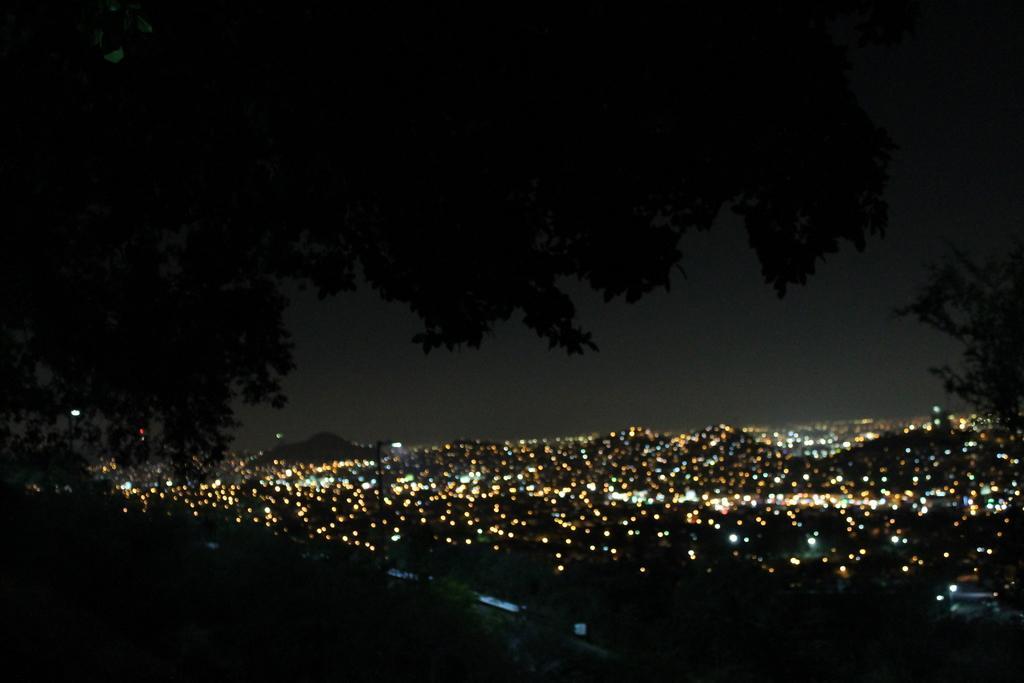Please provide a concise description of this image. In this picture we can see some lights and trees in the background. 